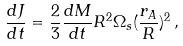<formula> <loc_0><loc_0><loc_500><loc_500>\frac { d J } { d t } = \frac { 2 } { 3 } \frac { d M } { d t } R ^ { 2 } \Omega _ { s } ( \frac { r _ { A } } { R } ) ^ { 2 } \, ,</formula> 